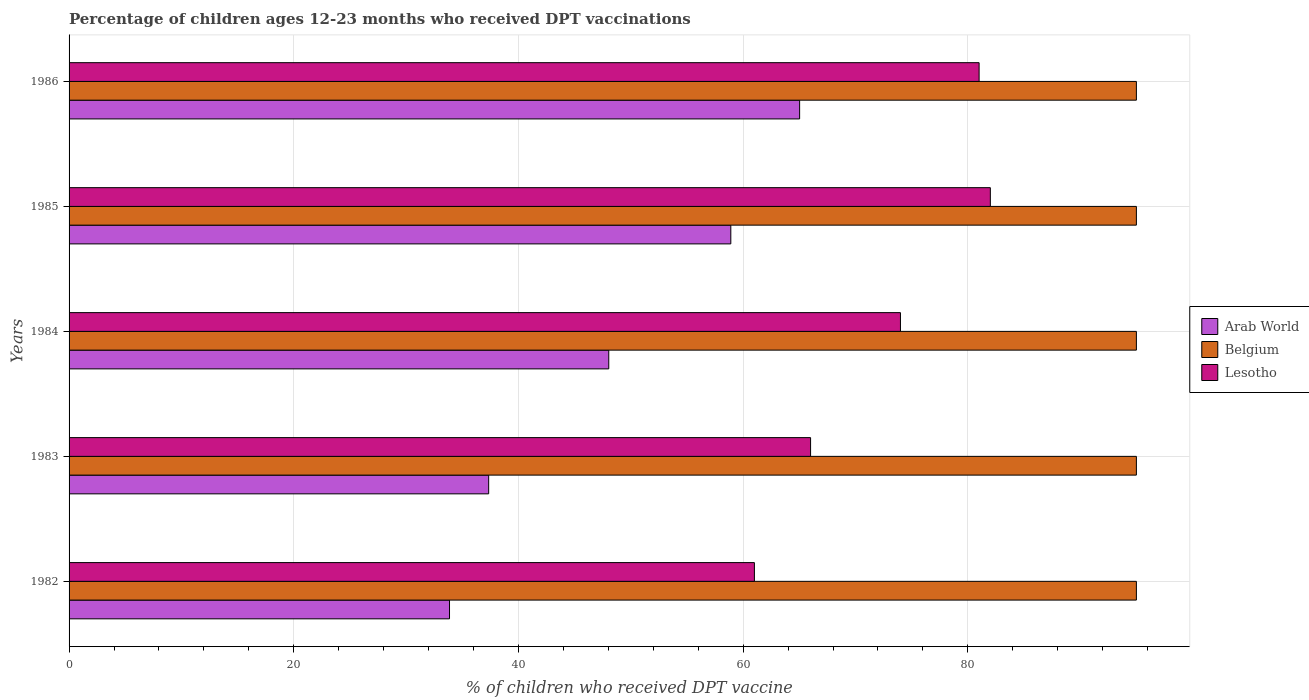How many groups of bars are there?
Keep it short and to the point. 5. Are the number of bars per tick equal to the number of legend labels?
Provide a succinct answer. Yes. How many bars are there on the 5th tick from the top?
Keep it short and to the point. 3. What is the label of the 4th group of bars from the top?
Your answer should be compact. 1983. What is the percentage of children who received DPT vaccination in Belgium in 1982?
Provide a short and direct response. 95. Across all years, what is the maximum percentage of children who received DPT vaccination in Lesotho?
Make the answer very short. 82. Across all years, what is the minimum percentage of children who received DPT vaccination in Lesotho?
Ensure brevity in your answer.  61. In which year was the percentage of children who received DPT vaccination in Belgium minimum?
Keep it short and to the point. 1982. What is the total percentage of children who received DPT vaccination in Belgium in the graph?
Provide a short and direct response. 475. What is the difference between the percentage of children who received DPT vaccination in Belgium in 1984 and the percentage of children who received DPT vaccination in Lesotho in 1986?
Ensure brevity in your answer.  14. In the year 1984, what is the difference between the percentage of children who received DPT vaccination in Belgium and percentage of children who received DPT vaccination in Arab World?
Make the answer very short. 46.96. In how many years, is the percentage of children who received DPT vaccination in Belgium greater than 80 %?
Keep it short and to the point. 5. Is the difference between the percentage of children who received DPT vaccination in Belgium in 1984 and 1985 greater than the difference between the percentage of children who received DPT vaccination in Arab World in 1984 and 1985?
Offer a very short reply. Yes. In how many years, is the percentage of children who received DPT vaccination in Lesotho greater than the average percentage of children who received DPT vaccination in Lesotho taken over all years?
Make the answer very short. 3. Is the sum of the percentage of children who received DPT vaccination in Lesotho in 1984 and 1985 greater than the maximum percentage of children who received DPT vaccination in Arab World across all years?
Provide a short and direct response. Yes. What does the 2nd bar from the top in 1984 represents?
Provide a succinct answer. Belgium. What does the 1st bar from the bottom in 1983 represents?
Your answer should be very brief. Arab World. Are all the bars in the graph horizontal?
Offer a terse response. Yes. How many years are there in the graph?
Your response must be concise. 5. Does the graph contain any zero values?
Provide a succinct answer. No. Where does the legend appear in the graph?
Your response must be concise. Center right. What is the title of the graph?
Keep it short and to the point. Percentage of children ages 12-23 months who received DPT vaccinations. Does "High income: nonOECD" appear as one of the legend labels in the graph?
Your answer should be very brief. No. What is the label or title of the X-axis?
Make the answer very short. % of children who received DPT vaccine. What is the % of children who received DPT vaccine of Arab World in 1982?
Give a very brief answer. 33.86. What is the % of children who received DPT vaccine of Belgium in 1982?
Your answer should be very brief. 95. What is the % of children who received DPT vaccine of Lesotho in 1982?
Your answer should be very brief. 61. What is the % of children who received DPT vaccine in Arab World in 1983?
Ensure brevity in your answer.  37.35. What is the % of children who received DPT vaccine of Arab World in 1984?
Make the answer very short. 48.04. What is the % of children who received DPT vaccine in Arab World in 1985?
Offer a very short reply. 58.9. What is the % of children who received DPT vaccine in Lesotho in 1985?
Make the answer very short. 82. What is the % of children who received DPT vaccine in Arab World in 1986?
Offer a very short reply. 65.03. What is the % of children who received DPT vaccine in Belgium in 1986?
Your answer should be very brief. 95. Across all years, what is the maximum % of children who received DPT vaccine of Arab World?
Offer a very short reply. 65.03. Across all years, what is the maximum % of children who received DPT vaccine in Belgium?
Keep it short and to the point. 95. Across all years, what is the maximum % of children who received DPT vaccine in Lesotho?
Your answer should be very brief. 82. Across all years, what is the minimum % of children who received DPT vaccine in Arab World?
Keep it short and to the point. 33.86. What is the total % of children who received DPT vaccine of Arab World in the graph?
Ensure brevity in your answer.  243.17. What is the total % of children who received DPT vaccine in Belgium in the graph?
Keep it short and to the point. 475. What is the total % of children who received DPT vaccine of Lesotho in the graph?
Keep it short and to the point. 364. What is the difference between the % of children who received DPT vaccine in Arab World in 1982 and that in 1983?
Offer a terse response. -3.48. What is the difference between the % of children who received DPT vaccine in Lesotho in 1982 and that in 1983?
Ensure brevity in your answer.  -5. What is the difference between the % of children who received DPT vaccine in Arab World in 1982 and that in 1984?
Offer a terse response. -14.17. What is the difference between the % of children who received DPT vaccine of Arab World in 1982 and that in 1985?
Your answer should be very brief. -25.04. What is the difference between the % of children who received DPT vaccine in Lesotho in 1982 and that in 1985?
Offer a very short reply. -21. What is the difference between the % of children who received DPT vaccine of Arab World in 1982 and that in 1986?
Give a very brief answer. -31.16. What is the difference between the % of children who received DPT vaccine of Lesotho in 1982 and that in 1986?
Offer a terse response. -20. What is the difference between the % of children who received DPT vaccine in Arab World in 1983 and that in 1984?
Give a very brief answer. -10.69. What is the difference between the % of children who received DPT vaccine in Belgium in 1983 and that in 1984?
Provide a succinct answer. 0. What is the difference between the % of children who received DPT vaccine in Lesotho in 1983 and that in 1984?
Offer a terse response. -8. What is the difference between the % of children who received DPT vaccine in Arab World in 1983 and that in 1985?
Your answer should be compact. -21.55. What is the difference between the % of children who received DPT vaccine in Belgium in 1983 and that in 1985?
Offer a very short reply. 0. What is the difference between the % of children who received DPT vaccine of Lesotho in 1983 and that in 1985?
Make the answer very short. -16. What is the difference between the % of children who received DPT vaccine in Arab World in 1983 and that in 1986?
Offer a very short reply. -27.68. What is the difference between the % of children who received DPT vaccine of Arab World in 1984 and that in 1985?
Keep it short and to the point. -10.86. What is the difference between the % of children who received DPT vaccine in Belgium in 1984 and that in 1985?
Your answer should be very brief. 0. What is the difference between the % of children who received DPT vaccine in Arab World in 1984 and that in 1986?
Make the answer very short. -16.99. What is the difference between the % of children who received DPT vaccine in Belgium in 1984 and that in 1986?
Offer a terse response. 0. What is the difference between the % of children who received DPT vaccine in Lesotho in 1984 and that in 1986?
Give a very brief answer. -7. What is the difference between the % of children who received DPT vaccine of Arab World in 1985 and that in 1986?
Your response must be concise. -6.12. What is the difference between the % of children who received DPT vaccine in Belgium in 1985 and that in 1986?
Your response must be concise. 0. What is the difference between the % of children who received DPT vaccine of Arab World in 1982 and the % of children who received DPT vaccine of Belgium in 1983?
Keep it short and to the point. -61.14. What is the difference between the % of children who received DPT vaccine in Arab World in 1982 and the % of children who received DPT vaccine in Lesotho in 1983?
Your response must be concise. -32.14. What is the difference between the % of children who received DPT vaccine in Belgium in 1982 and the % of children who received DPT vaccine in Lesotho in 1983?
Your answer should be very brief. 29. What is the difference between the % of children who received DPT vaccine of Arab World in 1982 and the % of children who received DPT vaccine of Belgium in 1984?
Your answer should be very brief. -61.14. What is the difference between the % of children who received DPT vaccine in Arab World in 1982 and the % of children who received DPT vaccine in Lesotho in 1984?
Provide a short and direct response. -40.14. What is the difference between the % of children who received DPT vaccine of Arab World in 1982 and the % of children who received DPT vaccine of Belgium in 1985?
Your response must be concise. -61.14. What is the difference between the % of children who received DPT vaccine in Arab World in 1982 and the % of children who received DPT vaccine in Lesotho in 1985?
Offer a terse response. -48.14. What is the difference between the % of children who received DPT vaccine in Belgium in 1982 and the % of children who received DPT vaccine in Lesotho in 1985?
Offer a terse response. 13. What is the difference between the % of children who received DPT vaccine of Arab World in 1982 and the % of children who received DPT vaccine of Belgium in 1986?
Give a very brief answer. -61.14. What is the difference between the % of children who received DPT vaccine of Arab World in 1982 and the % of children who received DPT vaccine of Lesotho in 1986?
Offer a terse response. -47.14. What is the difference between the % of children who received DPT vaccine of Belgium in 1982 and the % of children who received DPT vaccine of Lesotho in 1986?
Offer a terse response. 14. What is the difference between the % of children who received DPT vaccine of Arab World in 1983 and the % of children who received DPT vaccine of Belgium in 1984?
Give a very brief answer. -57.65. What is the difference between the % of children who received DPT vaccine in Arab World in 1983 and the % of children who received DPT vaccine in Lesotho in 1984?
Your response must be concise. -36.65. What is the difference between the % of children who received DPT vaccine in Belgium in 1983 and the % of children who received DPT vaccine in Lesotho in 1984?
Ensure brevity in your answer.  21. What is the difference between the % of children who received DPT vaccine in Arab World in 1983 and the % of children who received DPT vaccine in Belgium in 1985?
Make the answer very short. -57.65. What is the difference between the % of children who received DPT vaccine in Arab World in 1983 and the % of children who received DPT vaccine in Lesotho in 1985?
Offer a very short reply. -44.65. What is the difference between the % of children who received DPT vaccine in Arab World in 1983 and the % of children who received DPT vaccine in Belgium in 1986?
Offer a terse response. -57.65. What is the difference between the % of children who received DPT vaccine in Arab World in 1983 and the % of children who received DPT vaccine in Lesotho in 1986?
Provide a short and direct response. -43.65. What is the difference between the % of children who received DPT vaccine in Arab World in 1984 and the % of children who received DPT vaccine in Belgium in 1985?
Your answer should be very brief. -46.96. What is the difference between the % of children who received DPT vaccine of Arab World in 1984 and the % of children who received DPT vaccine of Lesotho in 1985?
Ensure brevity in your answer.  -33.96. What is the difference between the % of children who received DPT vaccine of Arab World in 1984 and the % of children who received DPT vaccine of Belgium in 1986?
Give a very brief answer. -46.96. What is the difference between the % of children who received DPT vaccine in Arab World in 1984 and the % of children who received DPT vaccine in Lesotho in 1986?
Offer a terse response. -32.96. What is the difference between the % of children who received DPT vaccine in Belgium in 1984 and the % of children who received DPT vaccine in Lesotho in 1986?
Your answer should be compact. 14. What is the difference between the % of children who received DPT vaccine of Arab World in 1985 and the % of children who received DPT vaccine of Belgium in 1986?
Keep it short and to the point. -36.1. What is the difference between the % of children who received DPT vaccine in Arab World in 1985 and the % of children who received DPT vaccine in Lesotho in 1986?
Make the answer very short. -22.1. What is the difference between the % of children who received DPT vaccine in Belgium in 1985 and the % of children who received DPT vaccine in Lesotho in 1986?
Ensure brevity in your answer.  14. What is the average % of children who received DPT vaccine in Arab World per year?
Your answer should be compact. 48.63. What is the average % of children who received DPT vaccine in Belgium per year?
Offer a terse response. 95. What is the average % of children who received DPT vaccine of Lesotho per year?
Offer a terse response. 72.8. In the year 1982, what is the difference between the % of children who received DPT vaccine of Arab World and % of children who received DPT vaccine of Belgium?
Give a very brief answer. -61.14. In the year 1982, what is the difference between the % of children who received DPT vaccine of Arab World and % of children who received DPT vaccine of Lesotho?
Your answer should be compact. -27.14. In the year 1982, what is the difference between the % of children who received DPT vaccine in Belgium and % of children who received DPT vaccine in Lesotho?
Keep it short and to the point. 34. In the year 1983, what is the difference between the % of children who received DPT vaccine in Arab World and % of children who received DPT vaccine in Belgium?
Give a very brief answer. -57.65. In the year 1983, what is the difference between the % of children who received DPT vaccine of Arab World and % of children who received DPT vaccine of Lesotho?
Offer a very short reply. -28.65. In the year 1983, what is the difference between the % of children who received DPT vaccine of Belgium and % of children who received DPT vaccine of Lesotho?
Ensure brevity in your answer.  29. In the year 1984, what is the difference between the % of children who received DPT vaccine of Arab World and % of children who received DPT vaccine of Belgium?
Keep it short and to the point. -46.96. In the year 1984, what is the difference between the % of children who received DPT vaccine of Arab World and % of children who received DPT vaccine of Lesotho?
Ensure brevity in your answer.  -25.96. In the year 1984, what is the difference between the % of children who received DPT vaccine in Belgium and % of children who received DPT vaccine in Lesotho?
Make the answer very short. 21. In the year 1985, what is the difference between the % of children who received DPT vaccine in Arab World and % of children who received DPT vaccine in Belgium?
Give a very brief answer. -36.1. In the year 1985, what is the difference between the % of children who received DPT vaccine in Arab World and % of children who received DPT vaccine in Lesotho?
Ensure brevity in your answer.  -23.1. In the year 1986, what is the difference between the % of children who received DPT vaccine in Arab World and % of children who received DPT vaccine in Belgium?
Provide a short and direct response. -29.97. In the year 1986, what is the difference between the % of children who received DPT vaccine in Arab World and % of children who received DPT vaccine in Lesotho?
Keep it short and to the point. -15.97. In the year 1986, what is the difference between the % of children who received DPT vaccine of Belgium and % of children who received DPT vaccine of Lesotho?
Ensure brevity in your answer.  14. What is the ratio of the % of children who received DPT vaccine of Arab World in 1982 to that in 1983?
Provide a short and direct response. 0.91. What is the ratio of the % of children who received DPT vaccine of Belgium in 1982 to that in 1983?
Your response must be concise. 1. What is the ratio of the % of children who received DPT vaccine in Lesotho in 1982 to that in 1983?
Keep it short and to the point. 0.92. What is the ratio of the % of children who received DPT vaccine in Arab World in 1982 to that in 1984?
Offer a terse response. 0.7. What is the ratio of the % of children who received DPT vaccine in Lesotho in 1982 to that in 1984?
Provide a short and direct response. 0.82. What is the ratio of the % of children who received DPT vaccine in Arab World in 1982 to that in 1985?
Make the answer very short. 0.57. What is the ratio of the % of children who received DPT vaccine of Belgium in 1982 to that in 1985?
Your answer should be compact. 1. What is the ratio of the % of children who received DPT vaccine of Lesotho in 1982 to that in 1985?
Offer a very short reply. 0.74. What is the ratio of the % of children who received DPT vaccine in Arab World in 1982 to that in 1986?
Provide a short and direct response. 0.52. What is the ratio of the % of children who received DPT vaccine of Lesotho in 1982 to that in 1986?
Provide a succinct answer. 0.75. What is the ratio of the % of children who received DPT vaccine of Arab World in 1983 to that in 1984?
Provide a short and direct response. 0.78. What is the ratio of the % of children who received DPT vaccine in Lesotho in 1983 to that in 1984?
Your response must be concise. 0.89. What is the ratio of the % of children who received DPT vaccine in Arab World in 1983 to that in 1985?
Give a very brief answer. 0.63. What is the ratio of the % of children who received DPT vaccine in Lesotho in 1983 to that in 1985?
Your answer should be very brief. 0.8. What is the ratio of the % of children who received DPT vaccine of Arab World in 1983 to that in 1986?
Provide a short and direct response. 0.57. What is the ratio of the % of children who received DPT vaccine of Belgium in 1983 to that in 1986?
Your answer should be very brief. 1. What is the ratio of the % of children who received DPT vaccine of Lesotho in 1983 to that in 1986?
Keep it short and to the point. 0.81. What is the ratio of the % of children who received DPT vaccine of Arab World in 1984 to that in 1985?
Your response must be concise. 0.82. What is the ratio of the % of children who received DPT vaccine of Belgium in 1984 to that in 1985?
Offer a very short reply. 1. What is the ratio of the % of children who received DPT vaccine of Lesotho in 1984 to that in 1985?
Your answer should be very brief. 0.9. What is the ratio of the % of children who received DPT vaccine in Arab World in 1984 to that in 1986?
Ensure brevity in your answer.  0.74. What is the ratio of the % of children who received DPT vaccine in Belgium in 1984 to that in 1986?
Make the answer very short. 1. What is the ratio of the % of children who received DPT vaccine of Lesotho in 1984 to that in 1986?
Your answer should be compact. 0.91. What is the ratio of the % of children who received DPT vaccine of Arab World in 1985 to that in 1986?
Your response must be concise. 0.91. What is the ratio of the % of children who received DPT vaccine of Lesotho in 1985 to that in 1986?
Your answer should be very brief. 1.01. What is the difference between the highest and the second highest % of children who received DPT vaccine of Arab World?
Offer a very short reply. 6.12. What is the difference between the highest and the second highest % of children who received DPT vaccine in Belgium?
Your answer should be very brief. 0. What is the difference between the highest and the lowest % of children who received DPT vaccine of Arab World?
Ensure brevity in your answer.  31.16. 